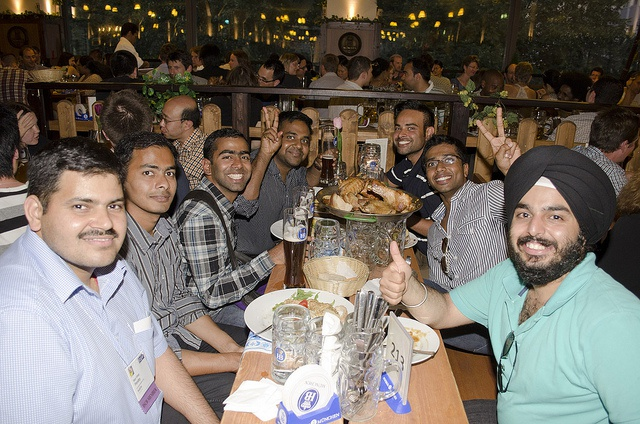Describe the objects in this image and their specific colors. I can see dining table in maroon, lightgray, darkgray, tan, and gray tones, people in maroon, lavender, tan, black, and darkgray tones, people in maroon, lightblue, black, tan, and darkgray tones, people in maroon, black, and gray tones, and people in maroon, darkgray, black, gray, and tan tones in this image. 